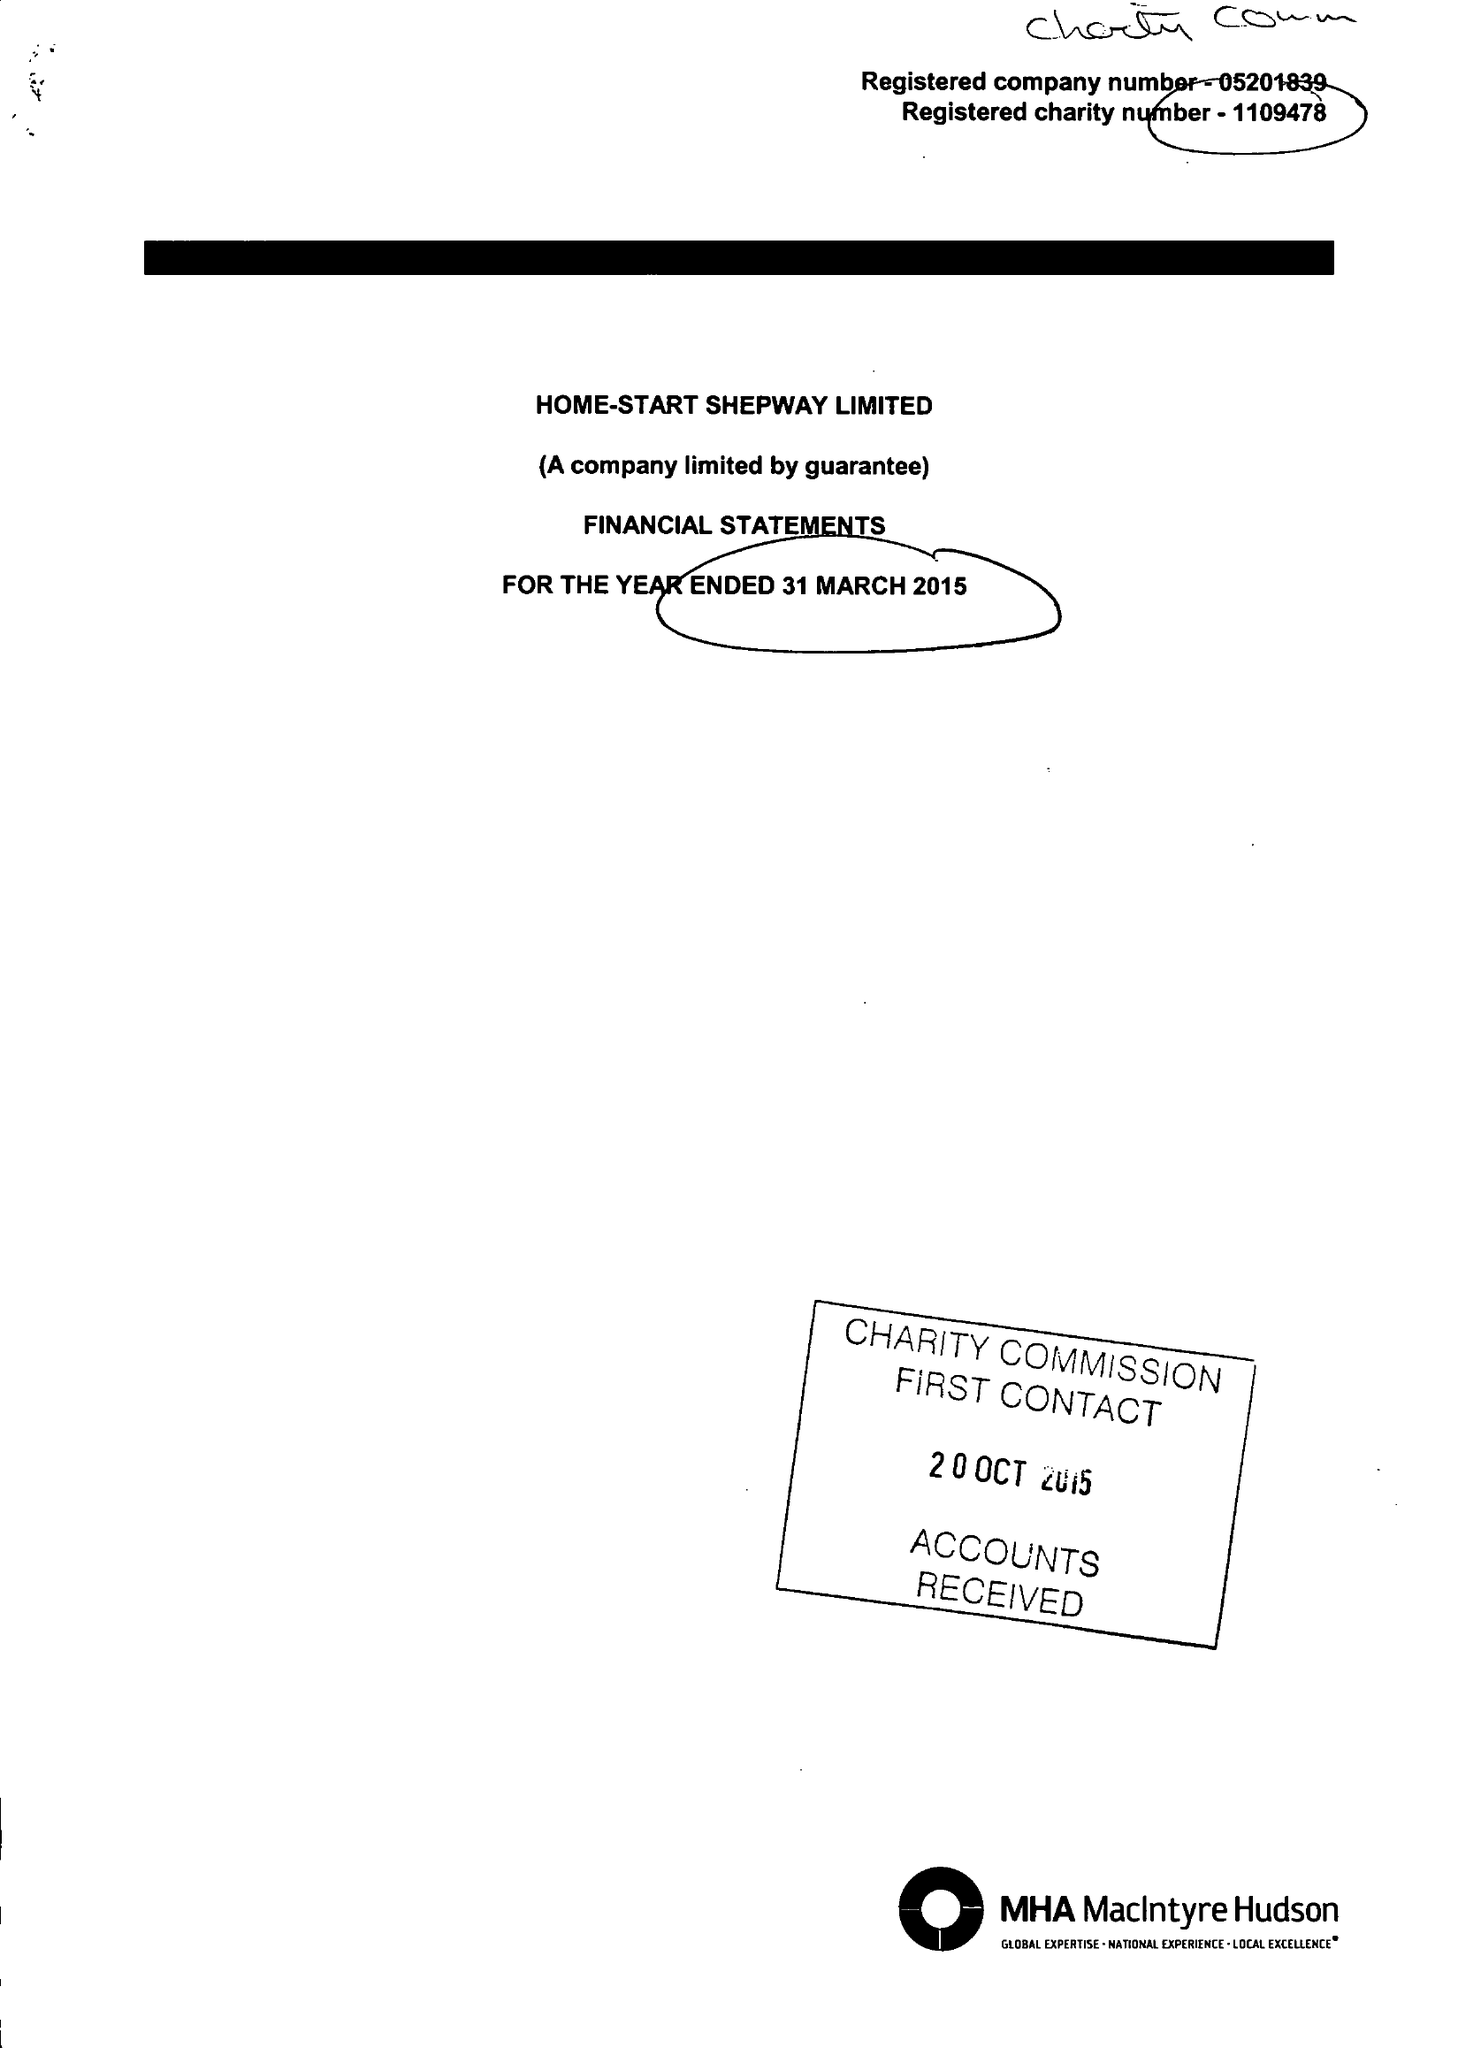What is the value for the charity_number?
Answer the question using a single word or phrase. 1109478 